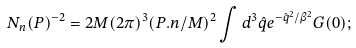Convert formula to latex. <formula><loc_0><loc_0><loc_500><loc_500>N _ { n } ( P ) ^ { - 2 } = 2 M ( 2 \pi ) ^ { 3 } ( P . n / M ) ^ { 2 } \int d ^ { 3 } { \hat { q } } e ^ { - { \hat { q } } ^ { 2 } / \beta ^ { 2 } } G ( 0 ) ;</formula> 